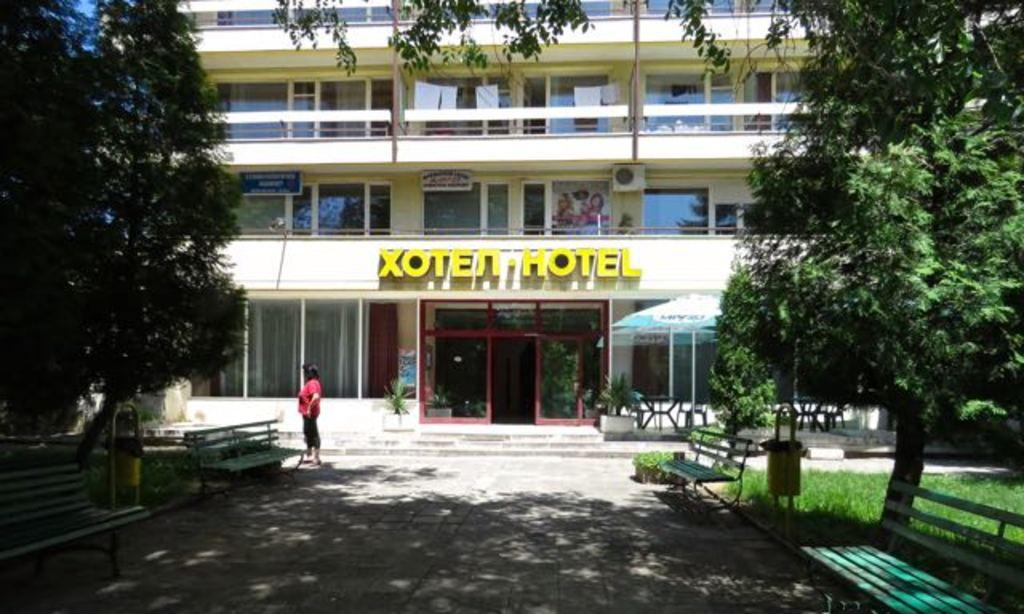What is the name of the building in the image? The building in the image is the "Xoten Hotel." Who or what is in front of the building? There is a woman standing in front of the building. What type of seating is available in the image? There are two benches in the image. What type of vegetation is present near the building? There are trees on either side of the building. What type of scissors are being used by the woman in the image? There are no scissors present in the image; the woman is simply standing in front of the building. 